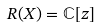Convert formula to latex. <formula><loc_0><loc_0><loc_500><loc_500>R ( X ) = \mathbb { C } [ z ]</formula> 